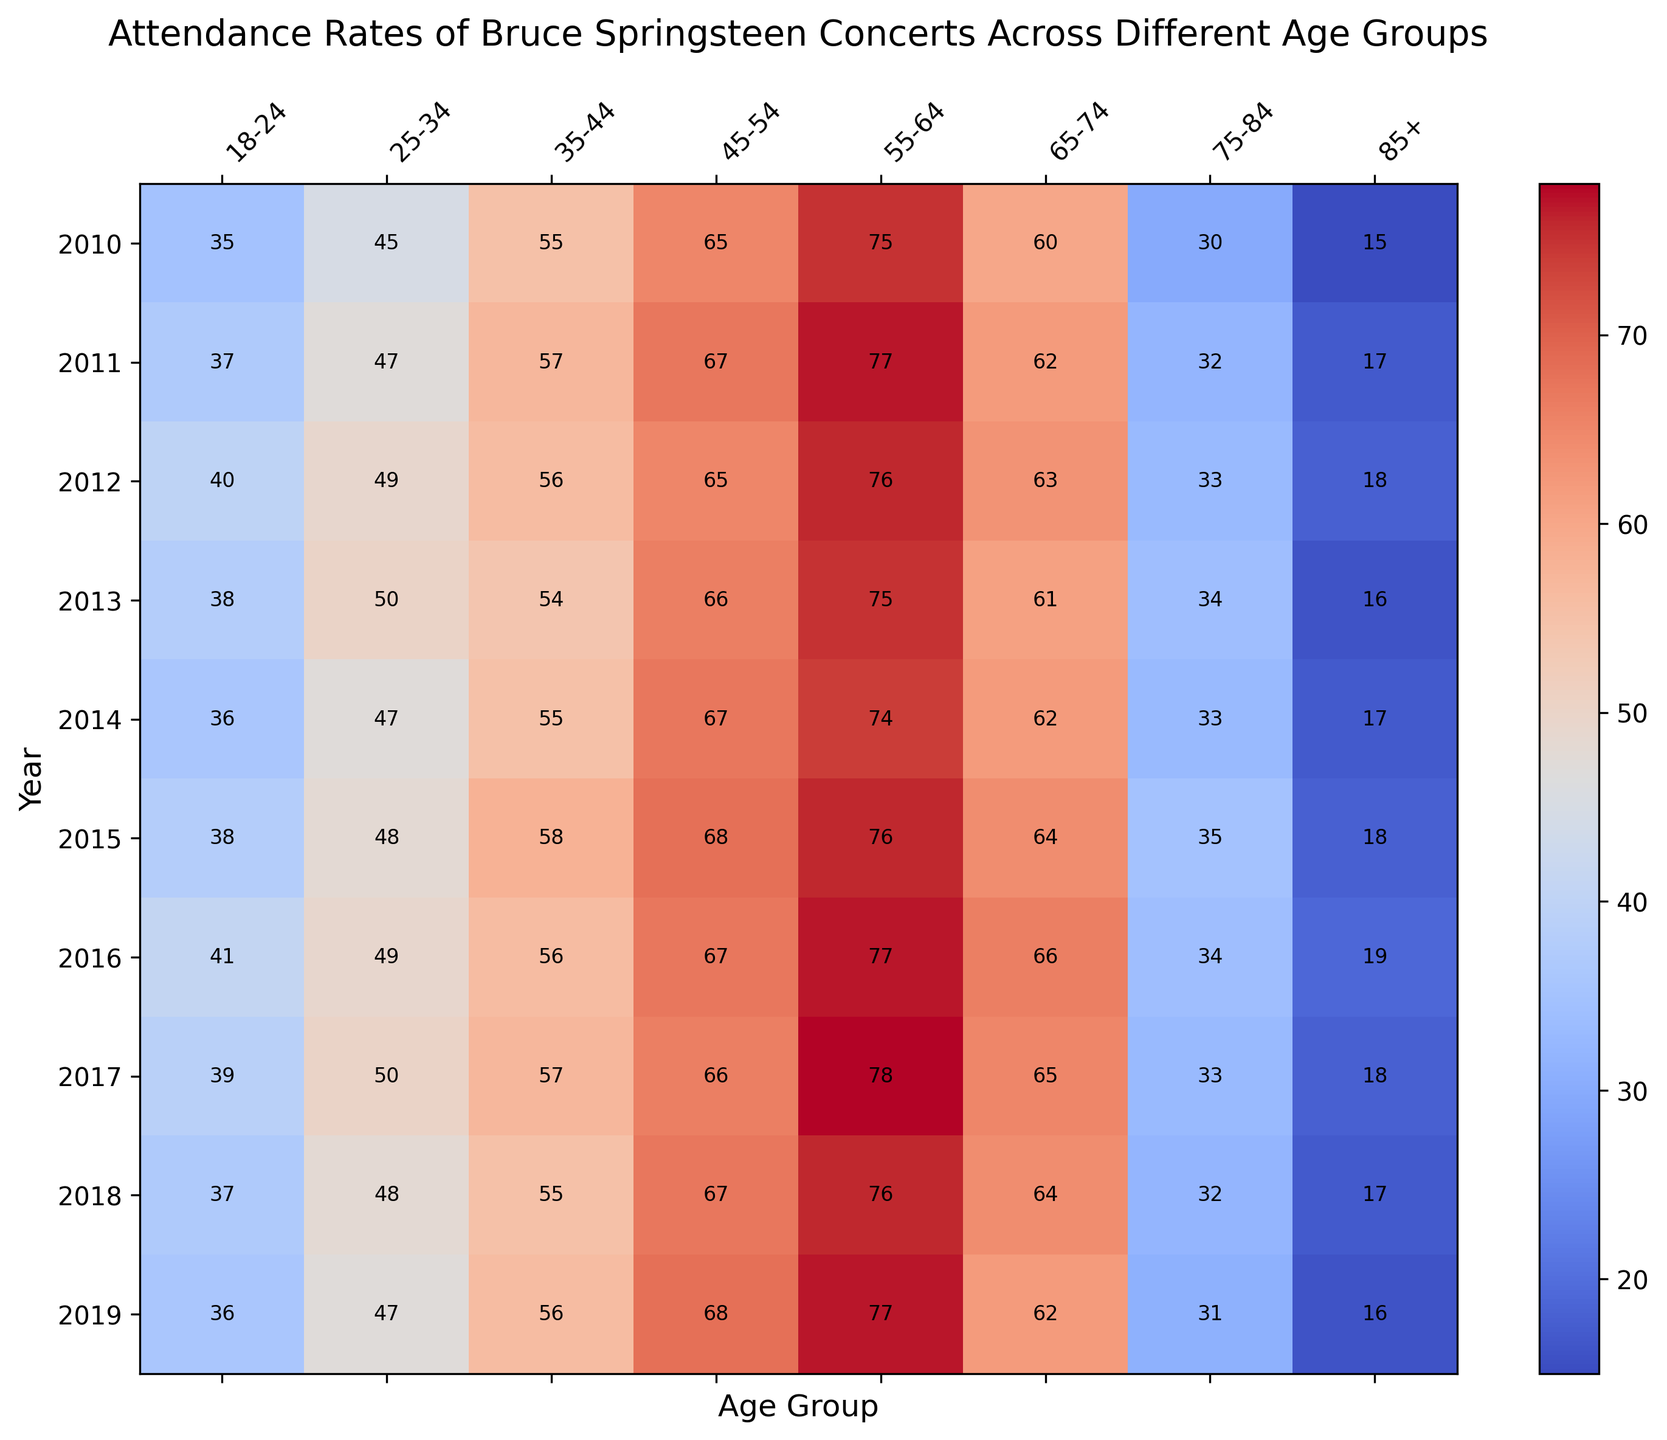Which age group had the highest attendance rate in 2010? By looking at the figure, the age group with the highest value in 2010 can be identified using the color intensity and annotations. The highest attendance rate in 2010 is represented with the brightest color and the biggest number, which is found for the 55-64 age group with a value of 75.
Answer: 55-64 How did the attendance rate for the 45-54 age group change from 2010 to 2019? To determine the change, subtract the attendance value of 2010 from the attendance value of 2019 for the 45-54 age group. In 2010, the attendance rate was 65, and in 2019, it was 68. Therefore, the change is 68 - 65 = 3.
Answer: Increased by 3 Which year had the lowest attendance rate for the 75-84 age group? To find the lowest attendance rate, look for the smallest number in the row corresponding to the 75-84 age group. By observing the annotations and colors, the value can be found to be lowest in 2010 with a value of 30.
Answer: 2010 Among all age groups, which one had the smallest increase in attendance rate from 2010 to 2019? Calculate the change for each age group by subtracting the 2010 value from the 2019 value, and then find the smallest change. For the 18-24 group: 36-35=1, 25-34: 47-45=2, 35-44: 56-55=1, 45-54: 68-65=3, 55-64: 77-75=2, 65-74: 62-60=2, 75-84: 31-30=1, 85+: 16-15=1. The smallest increase is 1, which occurred in multiple age groups (18-24, 35-44, 75-84, 85+).
Answer: 18-24, 35-44, 75-84, 85+ Which age group showed a consistent increase in attendance rate every year from 2010 to 2019? Check each age group's values year by year to see if the attendance rate increases every year without any decrease or plateau. The 25-34 age group consistently shows values increasing every year.
Answer: 25-34 What is the average attendance rate for the 65-74 age group across all years shown? To find the average, sum the attendance rates of the 65-74 age group from 2010 to 2019 and then divide by the number of years. Sum: 60+62+63+61+62+64+66+65+64+62 = 629. Number of years = 10. Average = 629 / 10.
Answer: 62.9 Which age group had the most dramatic decrease in attendance rate in any single year? To find the most dramatic decrease, look for the biggest drop in values between consecutive years. The most dramatic decrease occurs for the 65-74 age group from 2018 to 2019, where the attendance rate dropped from 64 to 62.
Answer: 65-74 (2018 to 2019) 